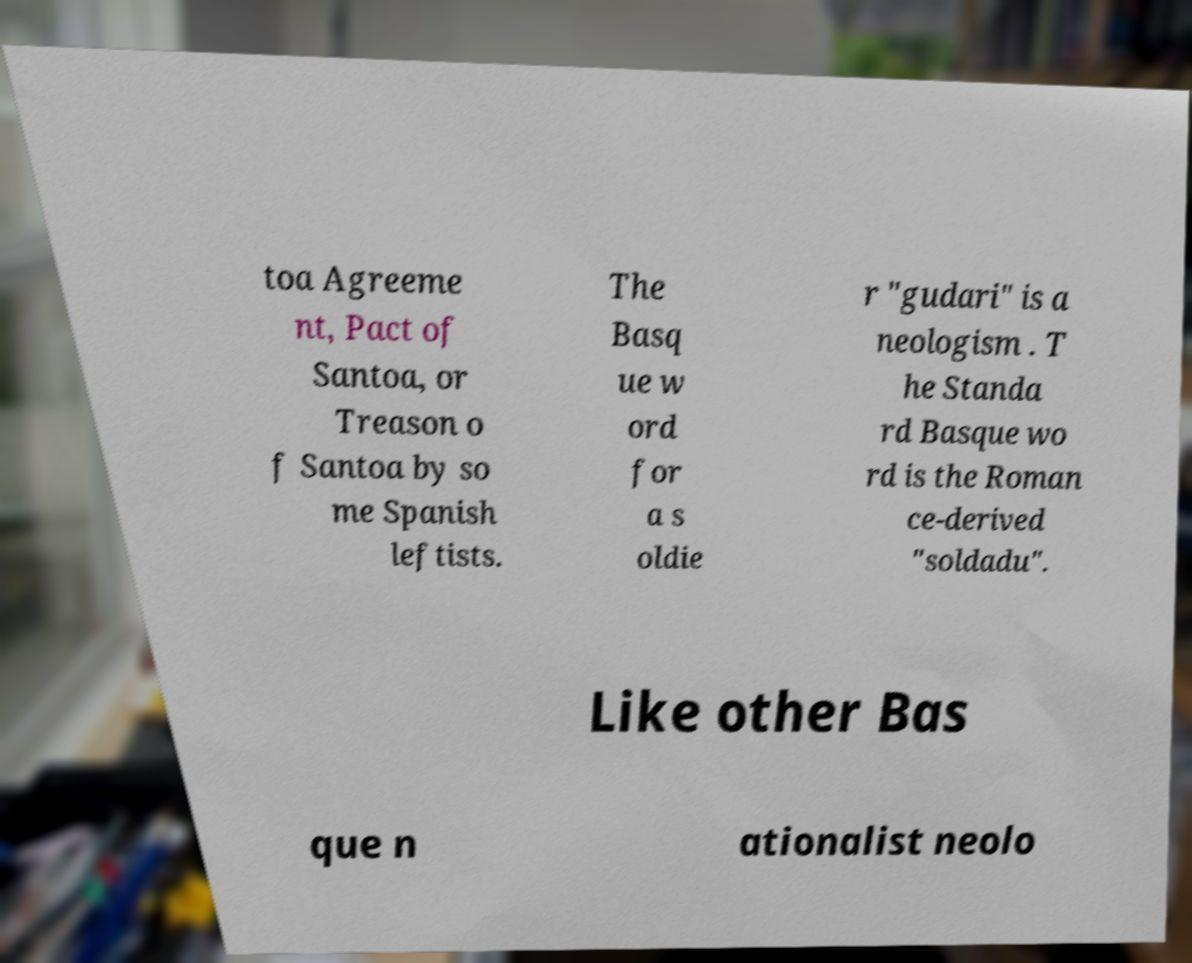Please read and relay the text visible in this image. What does it say? toa Agreeme nt, Pact of Santoa, or Treason o f Santoa by so me Spanish leftists. The Basq ue w ord for a s oldie r "gudari" is a neologism . T he Standa rd Basque wo rd is the Roman ce-derived "soldadu". Like other Bas que n ationalist neolo 